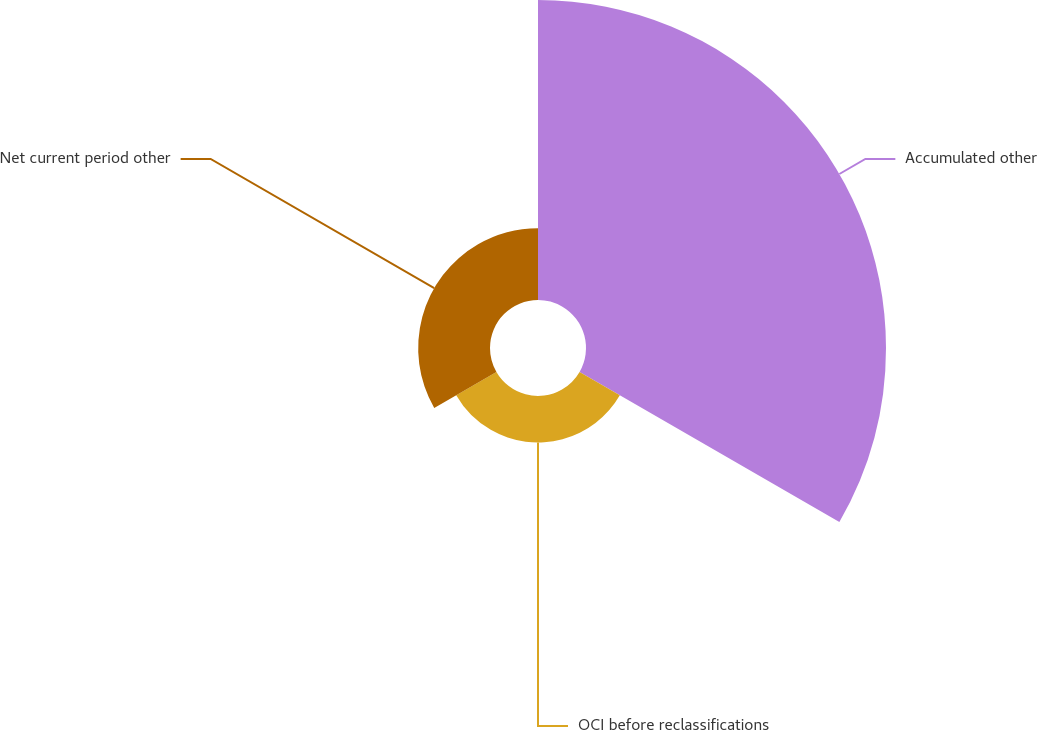Convert chart to OTSL. <chart><loc_0><loc_0><loc_500><loc_500><pie_chart><fcel>Accumulated other<fcel>OCI before reclassifications<fcel>Net current period other<nl><fcel>71.72%<fcel>11.11%<fcel>17.17%<nl></chart> 